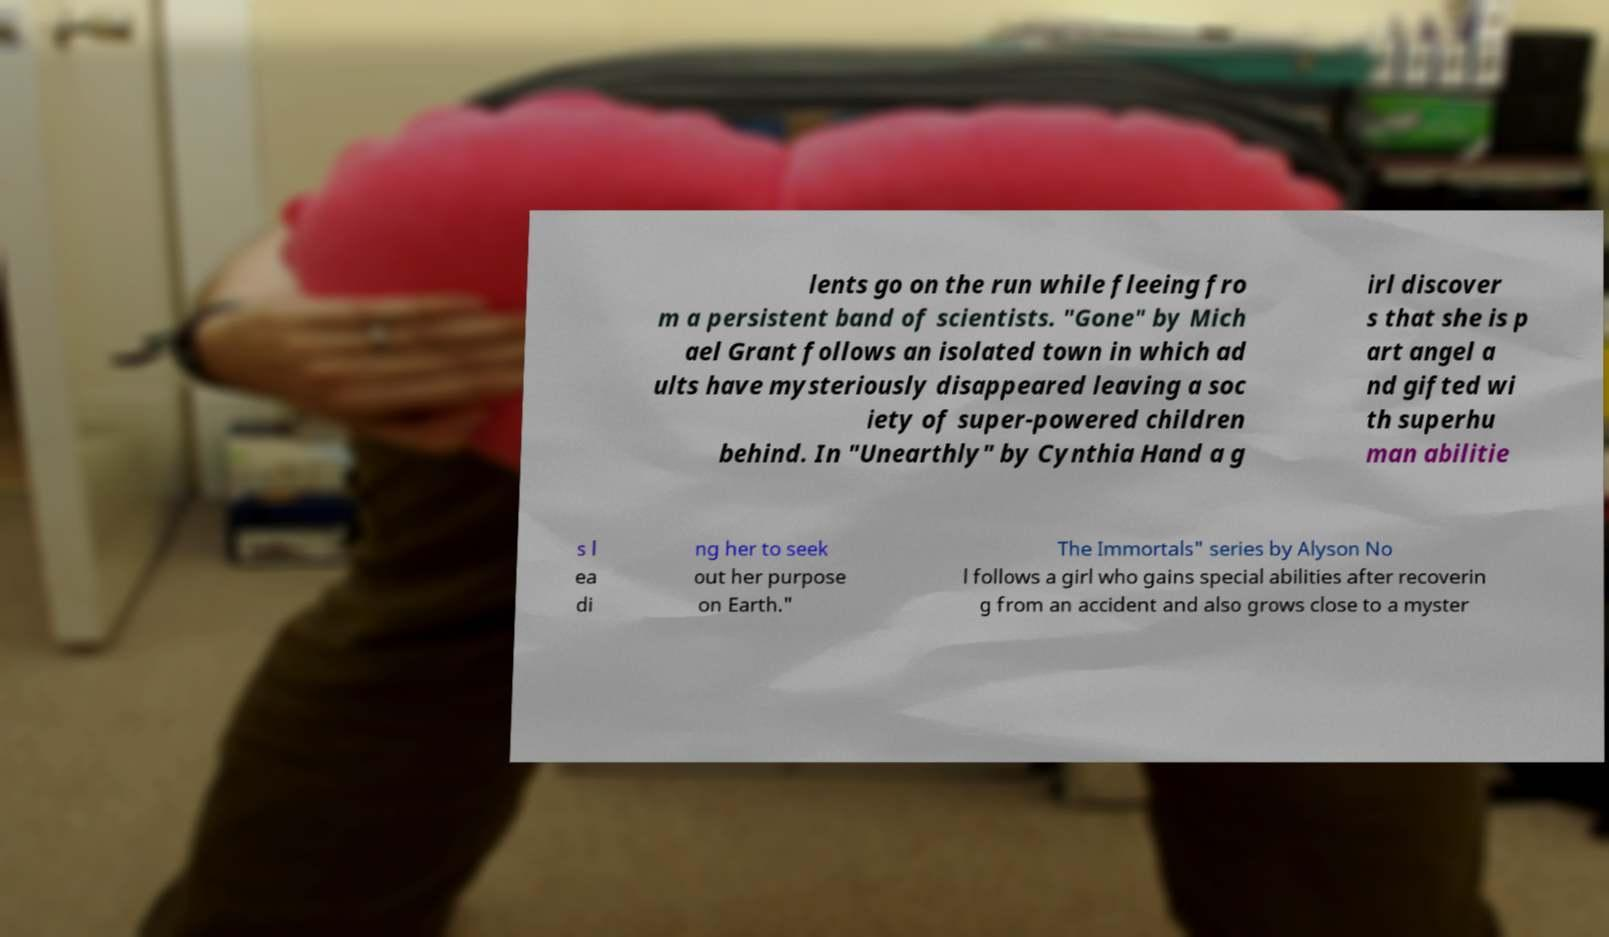Can you accurately transcribe the text from the provided image for me? lents go on the run while fleeing fro m a persistent band of scientists. "Gone" by Mich ael Grant follows an isolated town in which ad ults have mysteriously disappeared leaving a soc iety of super-powered children behind. In "Unearthly" by Cynthia Hand a g irl discover s that she is p art angel a nd gifted wi th superhu man abilitie s l ea di ng her to seek out her purpose on Earth." The Immortals" series by Alyson No l follows a girl who gains special abilities after recoverin g from an accident and also grows close to a myster 